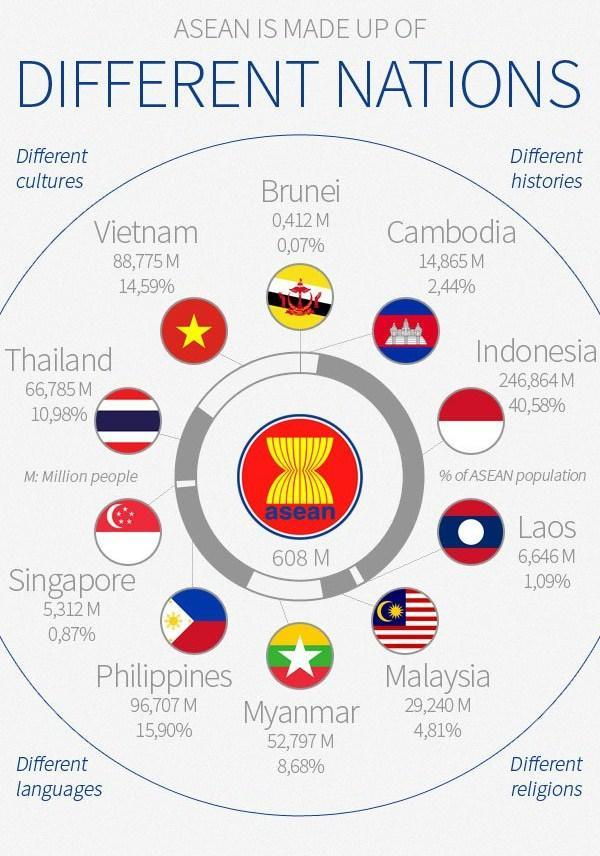What is the total population of the ASEAN countries?
Answer the question with a short phrase. 608 M Which ASEAN country has the lowest population percentage? Brunei Which ASEAN country has the highest population in millions? Indonesia Which of the three has a lower population percentage, Laos, Singapore, or Cambodia? Singapore How many countries are a part of ASEAN? 10 What is the population percentage of Malaysia, 15.90%, 8.68% or 4.81%? 4.81% What is the population of Vietnam in millions? 88,775 M 